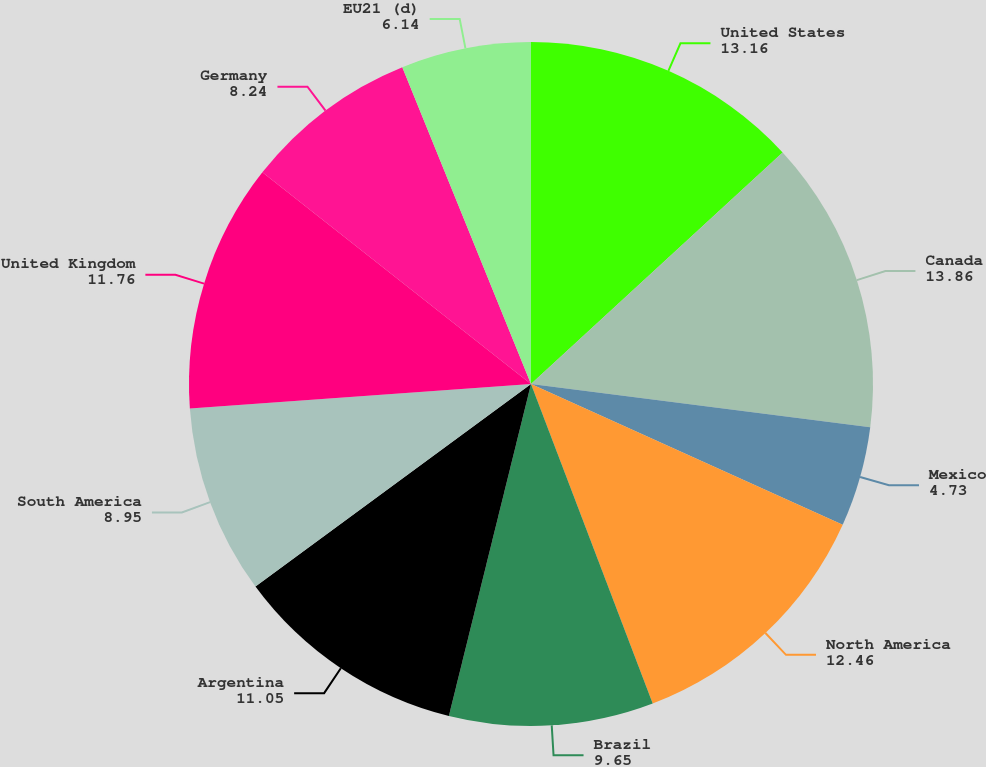Convert chart to OTSL. <chart><loc_0><loc_0><loc_500><loc_500><pie_chart><fcel>United States<fcel>Canada<fcel>Mexico<fcel>North America<fcel>Brazil<fcel>Argentina<fcel>South America<fcel>United Kingdom<fcel>Germany<fcel>EU21 (d)<nl><fcel>13.16%<fcel>13.86%<fcel>4.73%<fcel>12.46%<fcel>9.65%<fcel>11.05%<fcel>8.95%<fcel>11.76%<fcel>8.24%<fcel>6.14%<nl></chart> 